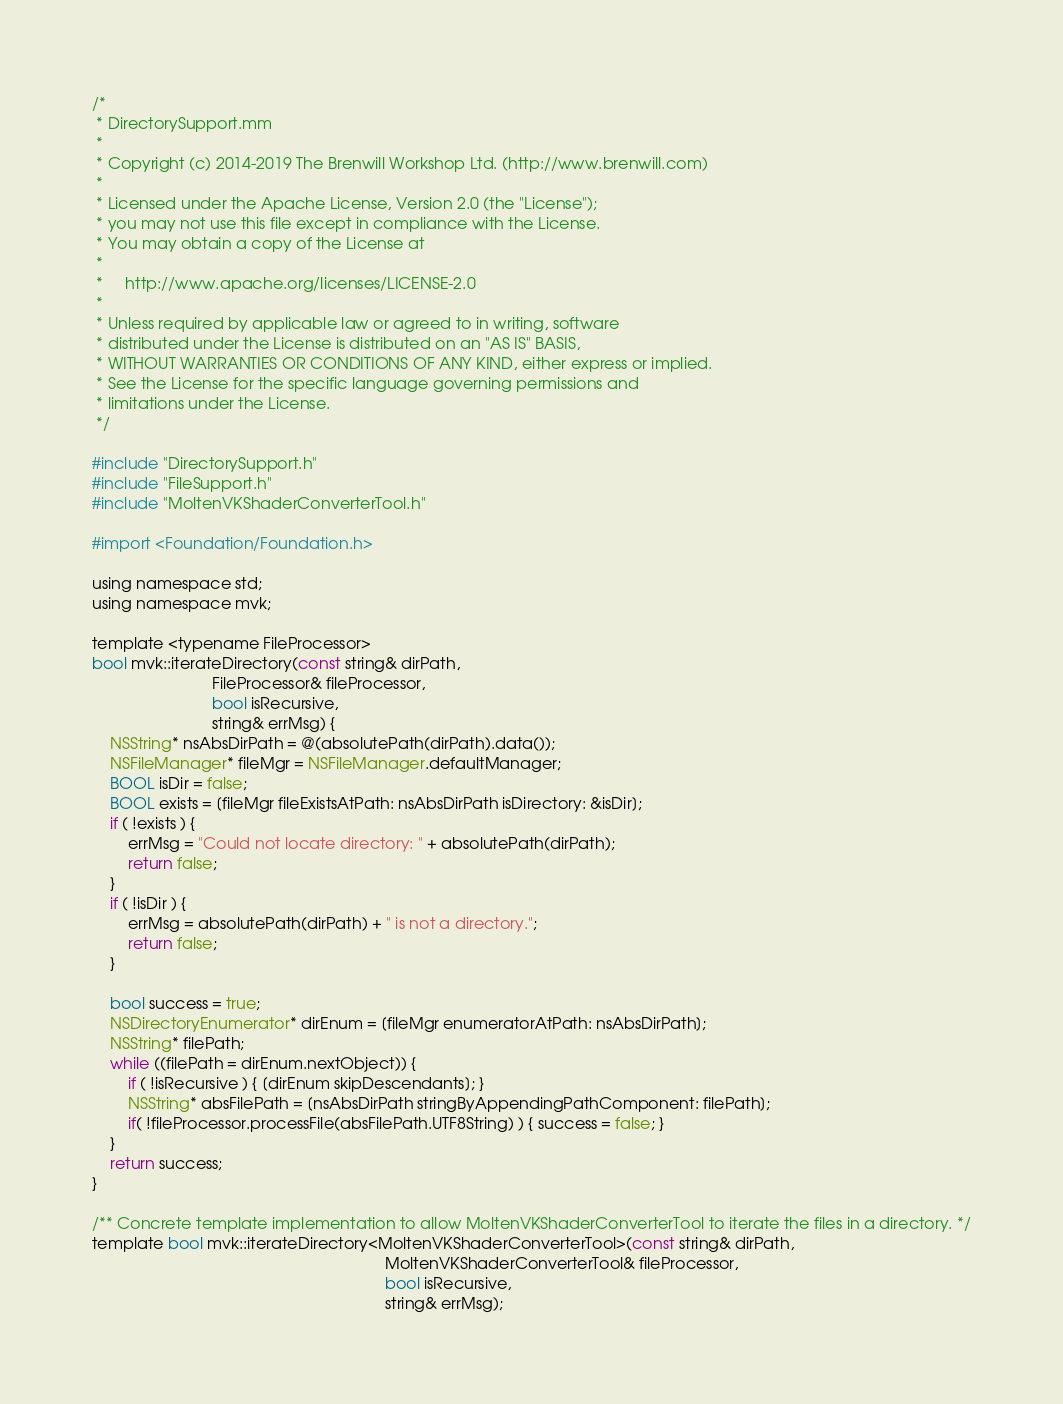<code> <loc_0><loc_0><loc_500><loc_500><_ObjectiveC_>/*
 * DirectorySupport.mm
 *
 * Copyright (c) 2014-2019 The Brenwill Workshop Ltd. (http://www.brenwill.com)
 *
 * Licensed under the Apache License, Version 2.0 (the "License");
 * you may not use this file except in compliance with the License.
 * You may obtain a copy of the License at
 * 
 *     http://www.apache.org/licenses/LICENSE-2.0
 * 
 * Unless required by applicable law or agreed to in writing, software
 * distributed under the License is distributed on an "AS IS" BASIS,
 * WITHOUT WARRANTIES OR CONDITIONS OF ANY KIND, either express or implied.
 * See the License for the specific language governing permissions and
 * limitations under the License.
 */

#include "DirectorySupport.h"
#include "FileSupport.h"
#include "MoltenVKShaderConverterTool.h"

#import <Foundation/Foundation.h>

using namespace std;
using namespace mvk;

template <typename FileProcessor>
bool mvk::iterateDirectory(const string& dirPath,
						   FileProcessor& fileProcessor,
						   bool isRecursive,
						   string& errMsg) {
	NSString* nsAbsDirPath = @(absolutePath(dirPath).data());
	NSFileManager* fileMgr = NSFileManager.defaultManager;
	BOOL isDir = false;
	BOOL exists = [fileMgr fileExistsAtPath: nsAbsDirPath isDirectory: &isDir];
	if ( !exists ) {
		errMsg = "Could not locate directory: " + absolutePath(dirPath);
		return false;
	}
	if ( !isDir ) {
		errMsg = absolutePath(dirPath) + " is not a directory.";
		return false;
	}

	bool success = true;
	NSDirectoryEnumerator* dirEnum = [fileMgr enumeratorAtPath: nsAbsDirPath];
	NSString* filePath;
	while ((filePath = dirEnum.nextObject)) {
		if ( !isRecursive ) { [dirEnum skipDescendants]; }
		NSString* absFilePath = [nsAbsDirPath stringByAppendingPathComponent: filePath];
		if( !fileProcessor.processFile(absFilePath.UTF8String) ) { success = false; }
	}
	return success;
}

/** Concrete template implementation to allow MoltenVKShaderConverterTool to iterate the files in a directory. */
template bool mvk::iterateDirectory<MoltenVKShaderConverterTool>(const string& dirPath,
																  MoltenVKShaderConverterTool& fileProcessor,
																  bool isRecursive,
																  string& errMsg);

</code> 